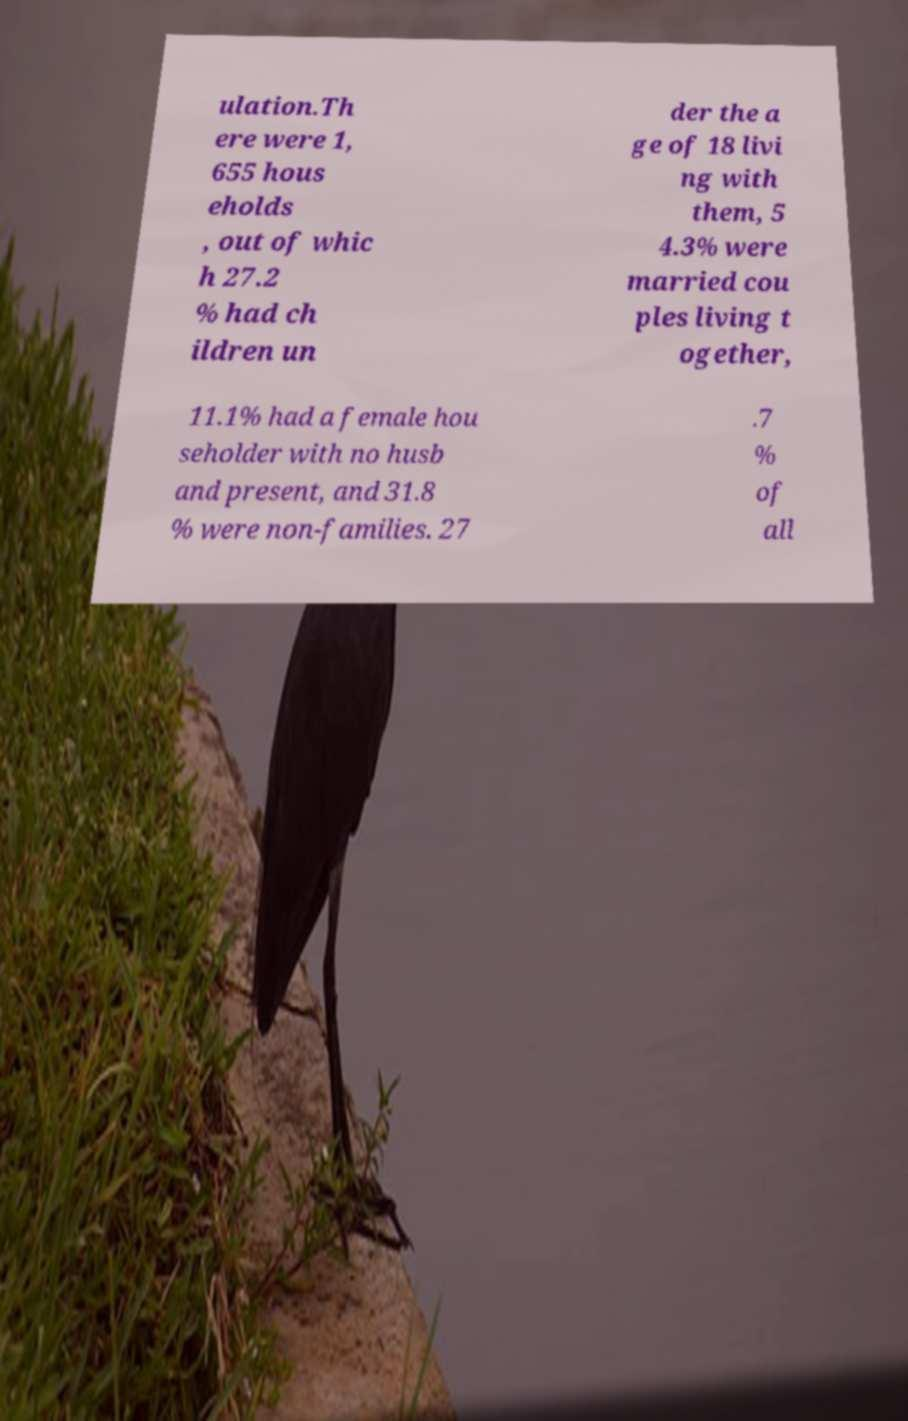Can you accurately transcribe the text from the provided image for me? ulation.Th ere were 1, 655 hous eholds , out of whic h 27.2 % had ch ildren un der the a ge of 18 livi ng with them, 5 4.3% were married cou ples living t ogether, 11.1% had a female hou seholder with no husb and present, and 31.8 % were non-families. 27 .7 % of all 